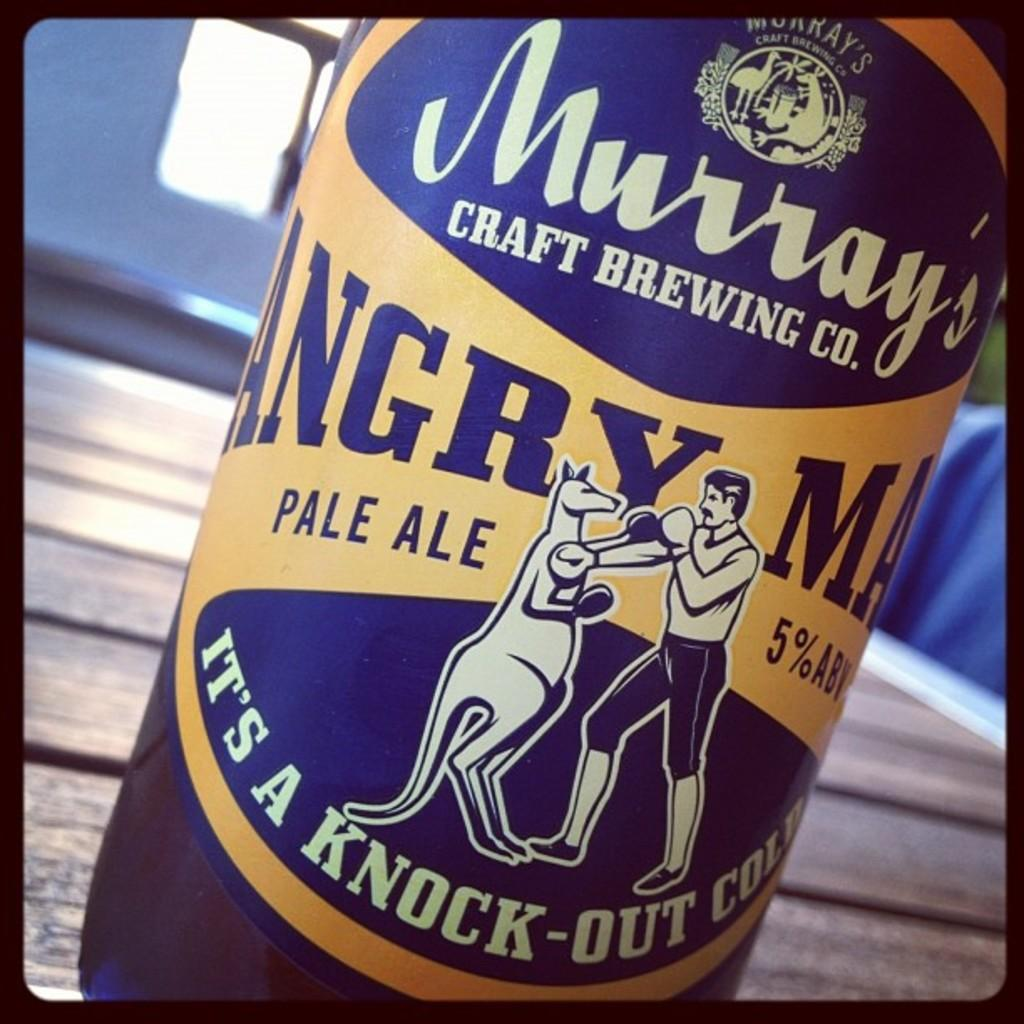<image>
Share a concise interpretation of the image provided. Murray's Craft Brewing Co. bottle depicting a man fighting a kangaroo. 